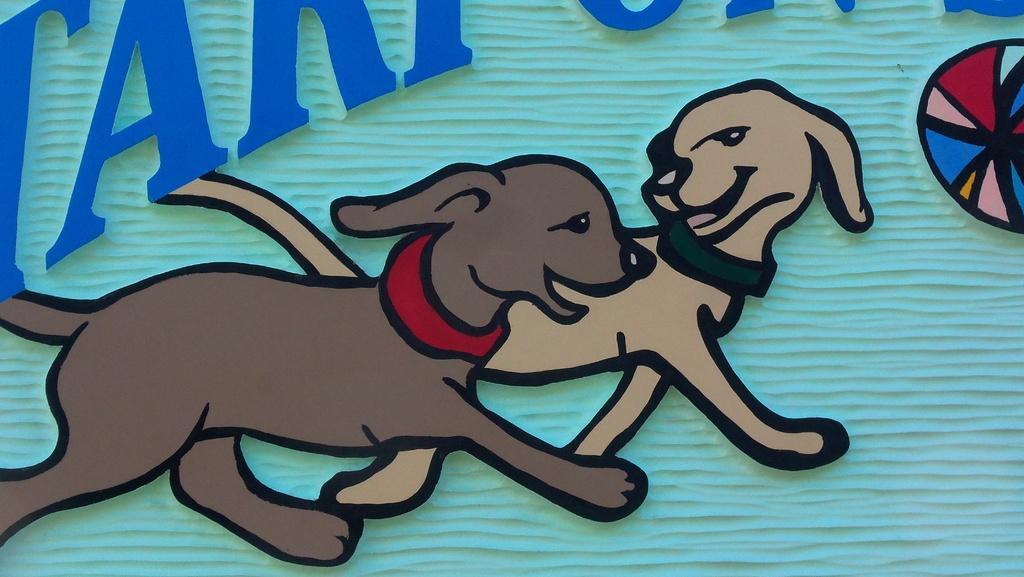How would you summarize this image in a sentence or two? In this picture we can see two dogs which are in brown and cream color. We can see these dogs are looking each other. There is a blue background. We can see a colorful object on the right side. 